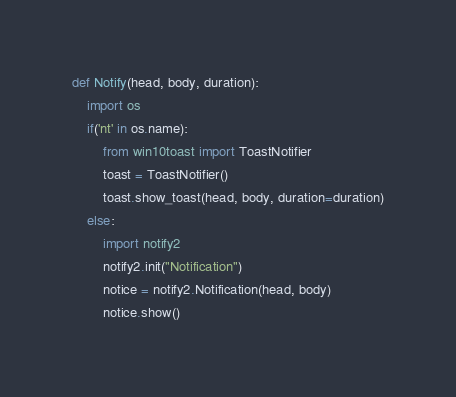<code> <loc_0><loc_0><loc_500><loc_500><_Python_>def Notify(head, body, duration):
    import os
    if('nt' in os.name):
        from win10toast import ToastNotifier
        toast = ToastNotifier()
        toast.show_toast(head, body, duration=duration)
    else:
        import notify2
        notify2.init("Notification")
        notice = notify2.Notification(head, body)
        notice.show()
</code> 